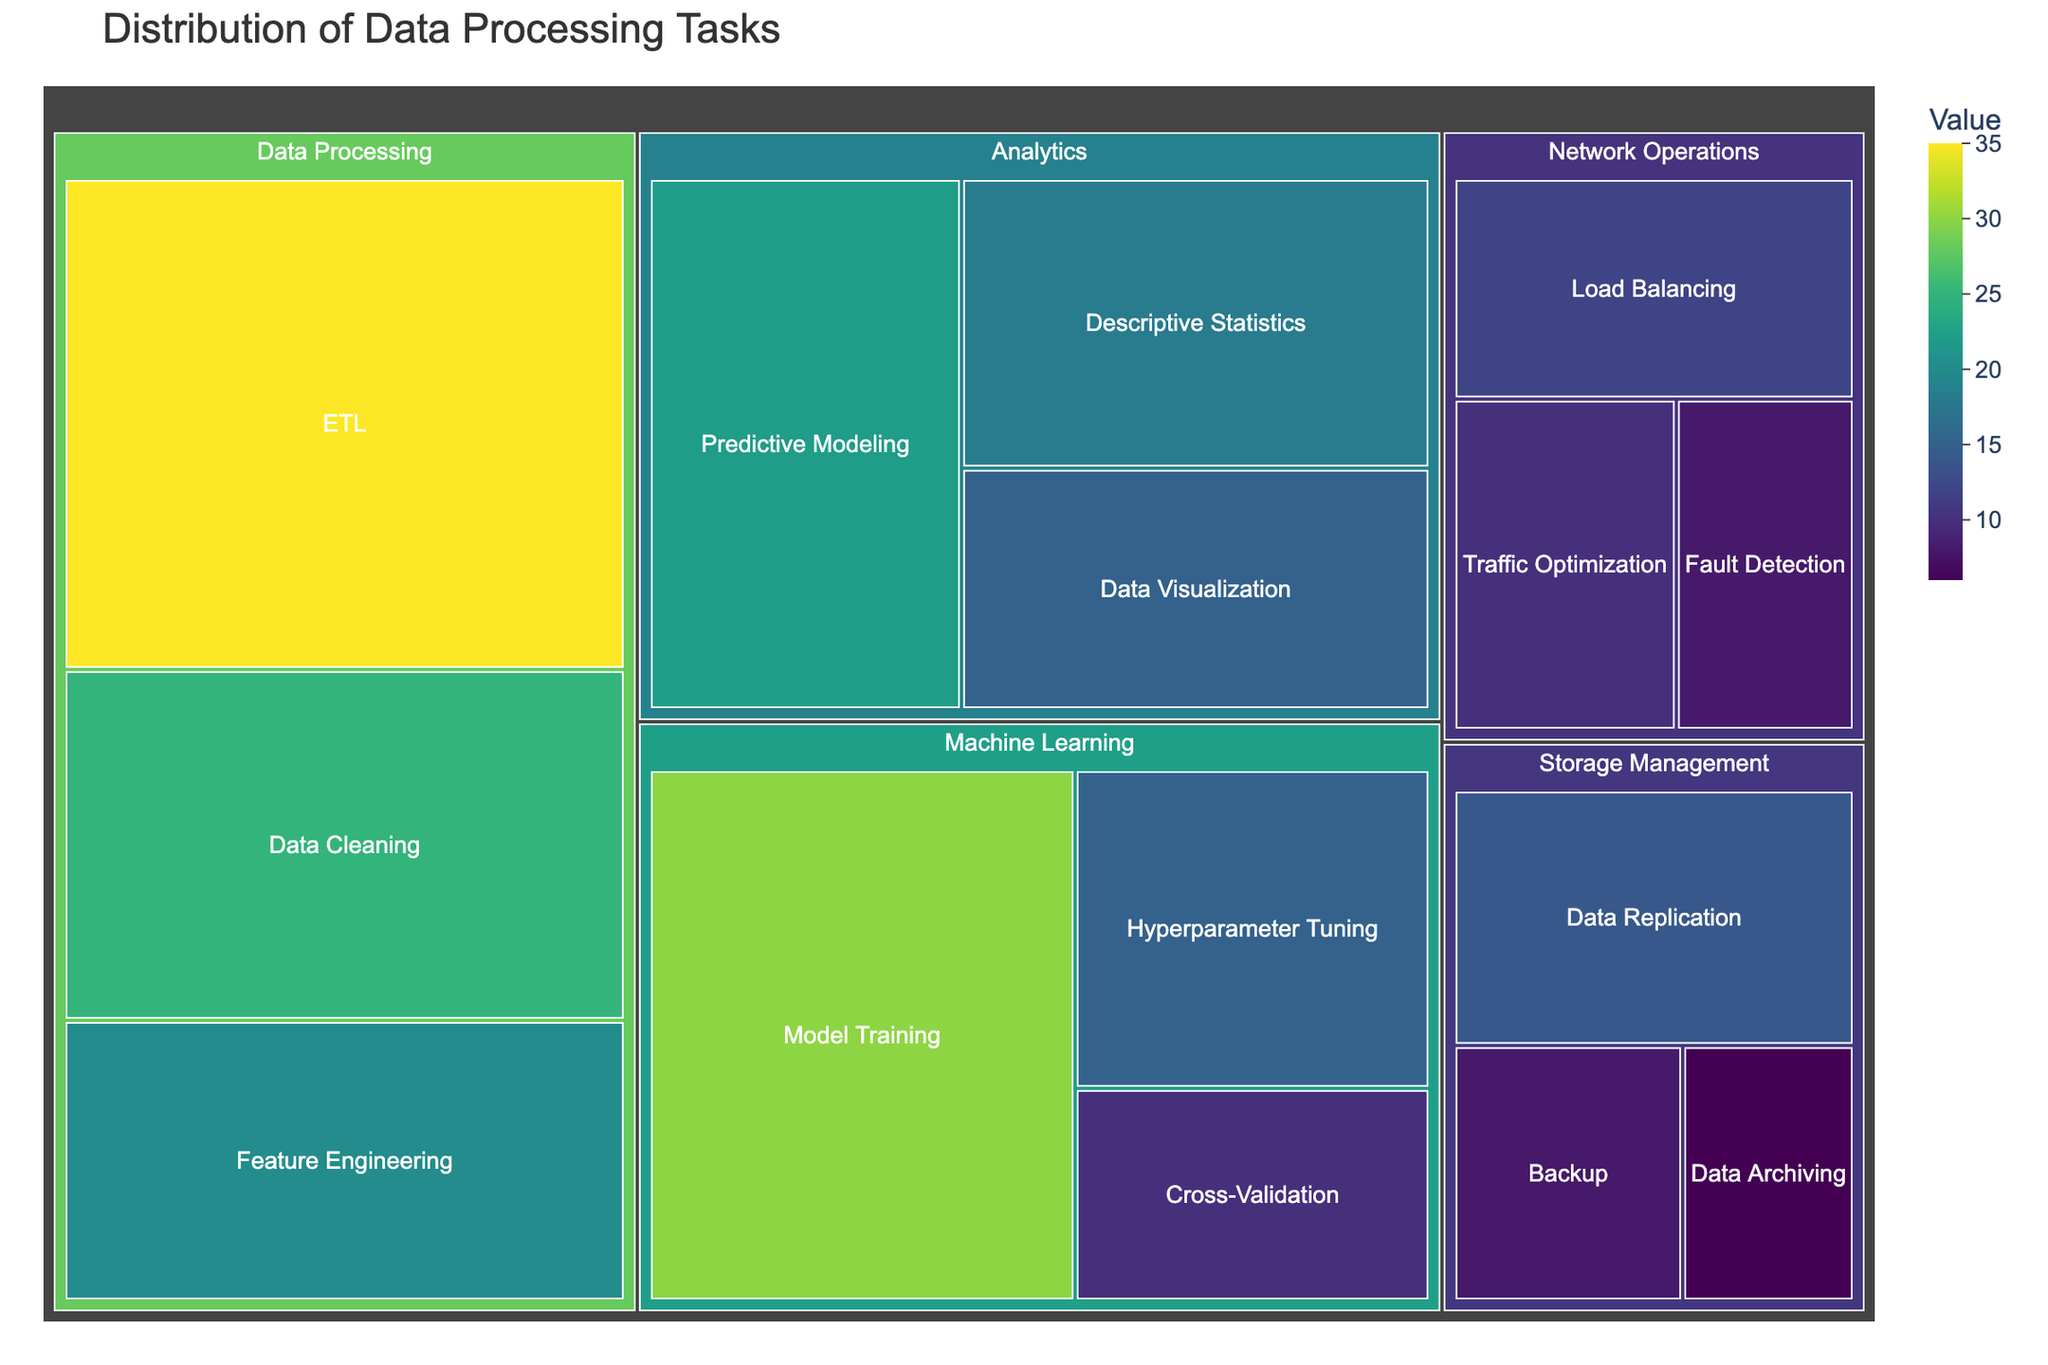What's the title of the treemap? The title is usually positioned at the top of the figure, utilized to describe the content or purpose of the treemap. Looking at the top of the figure, you'll see the title that reads "Distribution of Data Processing Tasks".
Answer: Distribution of Data Processing Tasks Which Subtask in Network Operations has the smallest value? Network Operations node has three subtasks: Load Balancing, Fault Detection, and Traffic Optimization. Observing the colors and size of these nodes, Fault Detection has the smallest area, which represents it as the subtask with the smallest value.
Answer: Fault Detection What's the total value of tasks under Machine Learning? Summing the values of subtasks under Machine Learning node: Model Training (30), Hyperparameter Tuning (15), and Cross-Validation (10), we get a total value of 30 + 15 + 10 = 55.
Answer: 55 Which Task has the highest aggregated value? We need to sum the values of each task group and compare: 
- Data Processing: ETL (35) + Data Cleaning (25) + Feature Engineering (20) = 80
- Machine Learning: Model Training (30) + Hyperparameter Tuning (15) + Cross-Validation (10) = 55
- Analytics: Descriptive Statistics (18) + Predictive Modeling (22) + Data Visualization (15) = 55
- Network Operations: Load Balancing (12) + Fault Detection (8) + Traffic Optimization (10) = 30
- Storage Management: Data Replication (14) + Backup (8) + Data Archiving (6) = 28
Comparing these sums, Data Processing has the highest value.
Answer: Data Processing Is the value of Data Archiving more or less than the value of Data Visualization? Data Archiving has a value of 6 while Data Visualization has a value of 15. Comparing these, Data Archiving is less than Data Visualization.
Answer: Less How many subtasks are there in total in the treemap? Count the number of nodes at the subtask level across all tasks: ETL, Data Cleaning, Feature Engineering, Model Training, Hyperparameter Tuning, Cross-Validation, Descriptive Statistics, Predictive Modeling, Data Visualization, Load Balancing, Fault Detection, Traffic Optimization, Data Replication, Backup, Data Archiving. This sums up to 15 subtasks in total.
Answer: 15 Among the Analytics subtasks, which one has the highest value? The subtasks under Analytics are Descriptive Statistics (18), Predictive Modeling (22), and Data Visualization (15). Comparing these values, Predictive Modeling has the highest value.
Answer: Predictive Modeling What can you infer about the diversity of task values from the color scale in the treemap? The treemap uses a color scale transition from lighter to darker shades of a preset color scheme to represent lower to higher values respectively. Observing the gradient and variety of colors, we see a range of values with more diverse and higher values in Data Processing.
Answer: The colors indicate a diverse range of values, with more diversity and higher values in Data Processing 